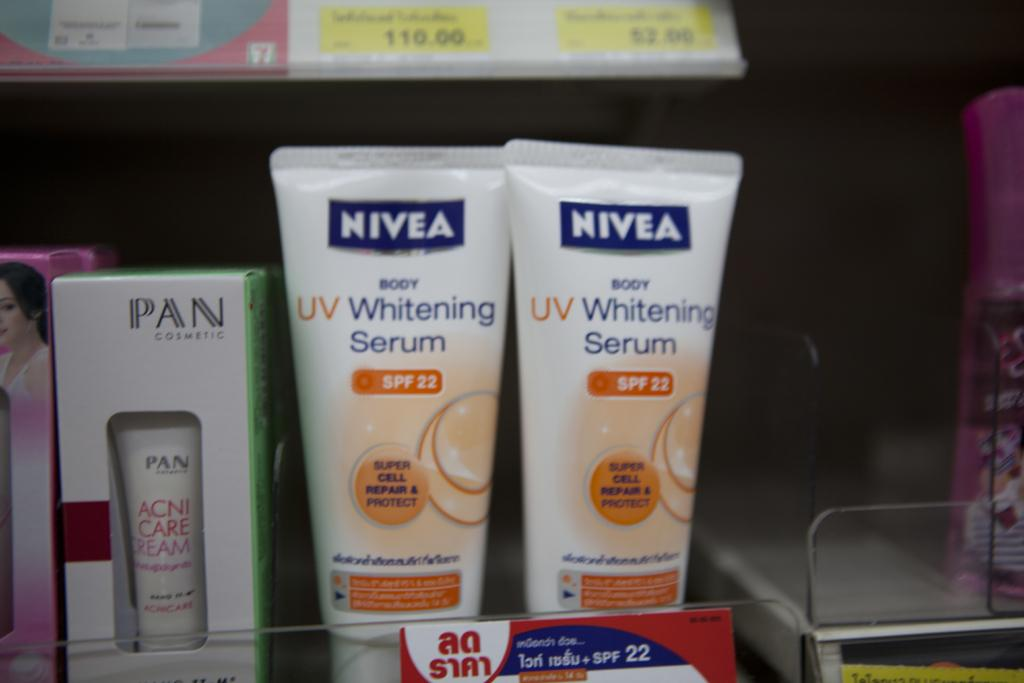Provide a one-sentence caption for the provided image. NIVEA UV Whitening Serum is printed on the front of these bottles. 